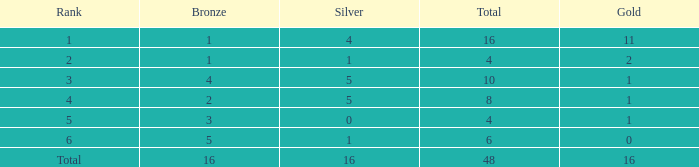How many gold are a rank 1 and larger than 16? 0.0. 